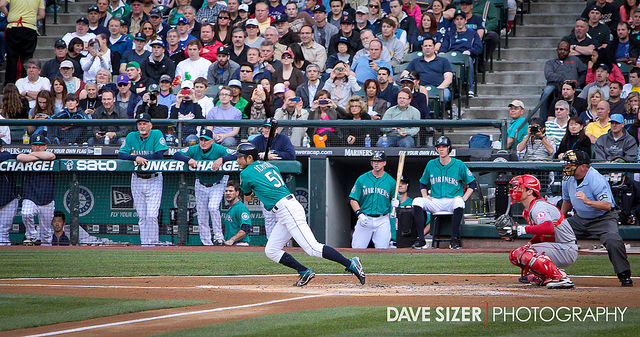Identify the text displayed in this image. CHARGER sato YUNKER PHOTOGRAPHY SIZER DAVE ER CHANGE 51 